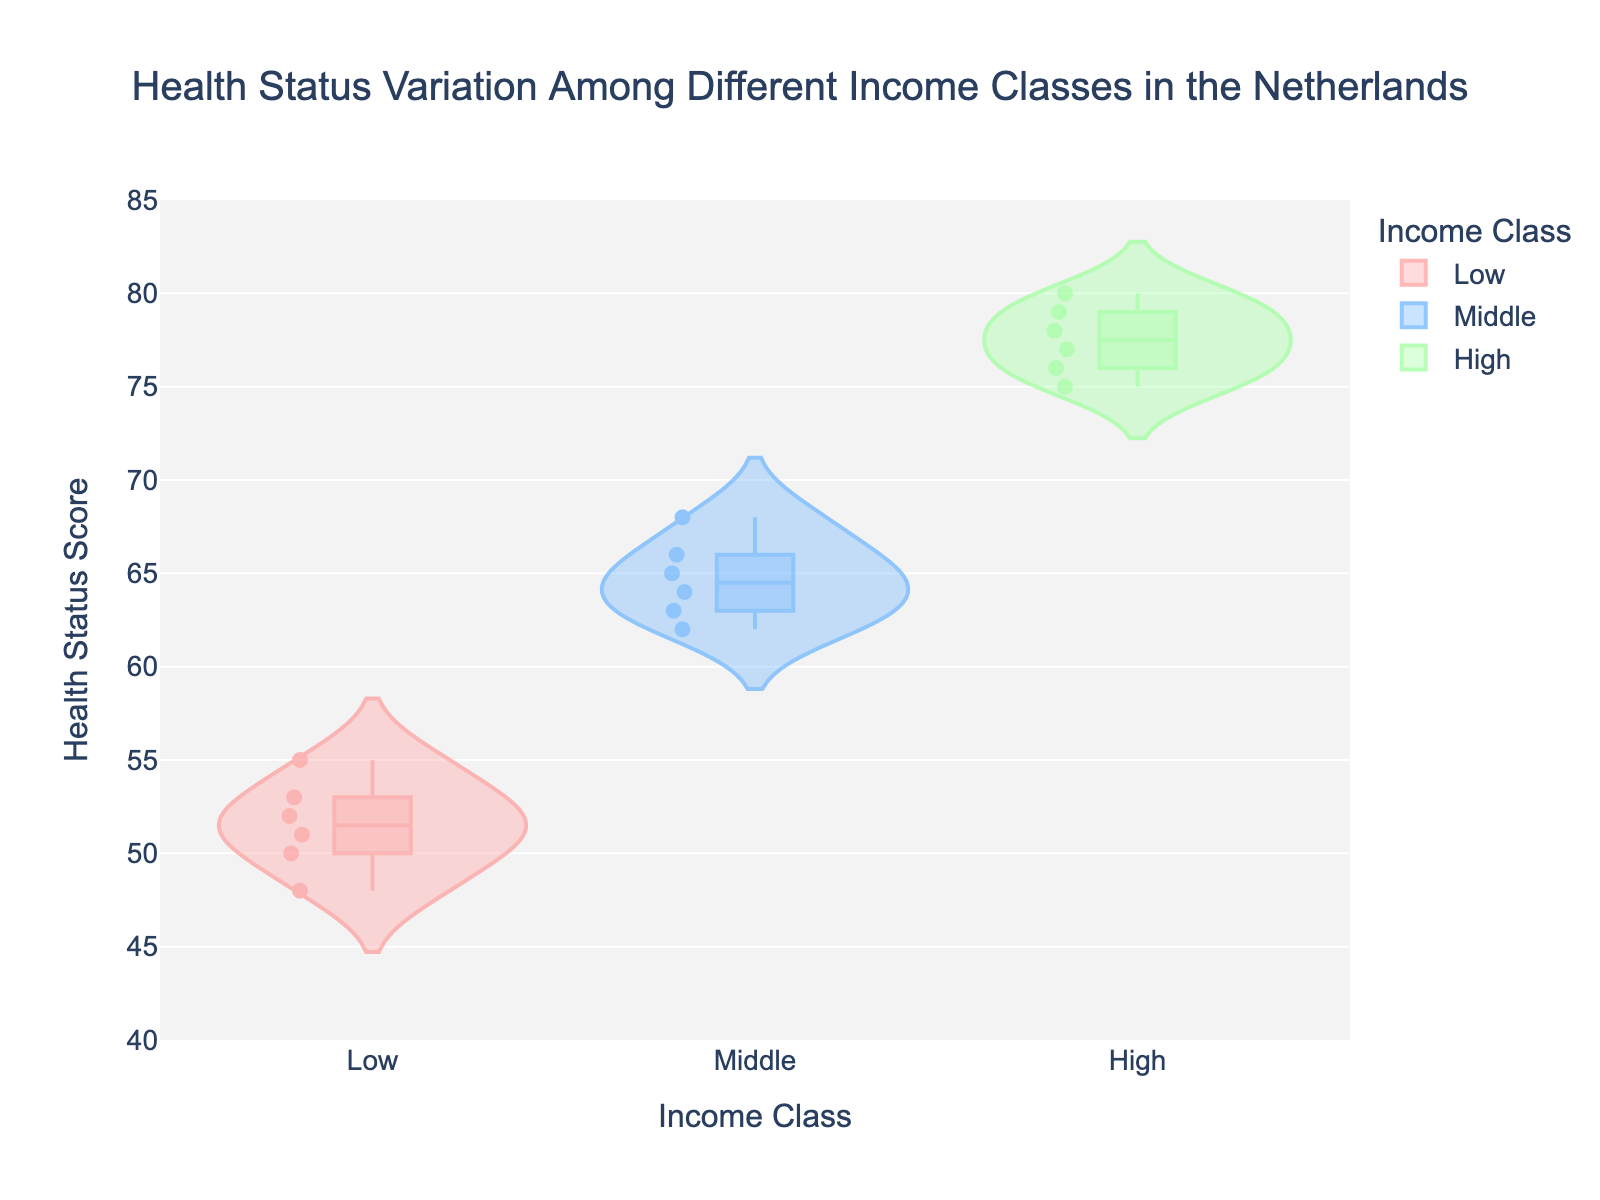What is the title of the chart? The title of the chart is displayed at the top and reads, "Health Status Variation Among Different Income Classes in the Netherlands".
Answer: Health Status Variation Among Different Income Classes in the Netherlands What does the y-axis represent? The y-axis represents the "Health_Status" scores, indicating various health status values.
Answer: Health_Status score Which income class shows the highest health status score? By observing the distribution of data points on the violin chart, the "High" income class has the highest health status score, which reaches up to 80.
Answer: High What are the median health status scores for each income class? The chart includes box plots within the violins. The median values can be read from these box plots, which are marked with a distinctive line. For "Low," it’s 51, for "Middle," it’s 65, and for "High," it’s 77.
Answer: Low: 51, Middle: 65, High: 77 Which income class has the widest range of health status scores? The range can be determined by observing the spread from the lowest to the highest points within each violin plot. The "High" income class has the widest range (75 to 80), spanning 5 units.
Answer: High How many health status scores are plotted for the middle-income class? The middle-income class contains 6 data points, as indicated by the plotted points within the violin for this class.
Answer: 6 What is the lowest health status score observed in the low-income class? The lowest health status score for the low-income class appears to be at 48, as seen from the bottom of the violin plot for this group.
Answer: 48 Compare the median health status score between the low-income and high-income classes. The median health status score for the low-income class is 51, and for the high-income class, it is 77. The high-income class's median score is 26 points higher than the low-income class's median.
Answer: 26 points higher What information is represented by the colorful areas in the violin plots? The colorful areas in the violin plots represent the density of data points within each income class, showing the distribution and frequency of health status scores. The wider sections indicate a higher density of scores at that level.
Answer: Density of data points How does the health status variation among different income classes compare visually? From the violin plots, it is evident that the high-income class has generally higher health status scores, while the middle-income class shows moderate scores, and the low-income class has the lowest scores overall. This indicates a positive correlation between income and health status.
Answer: Positive correlation between income and health 